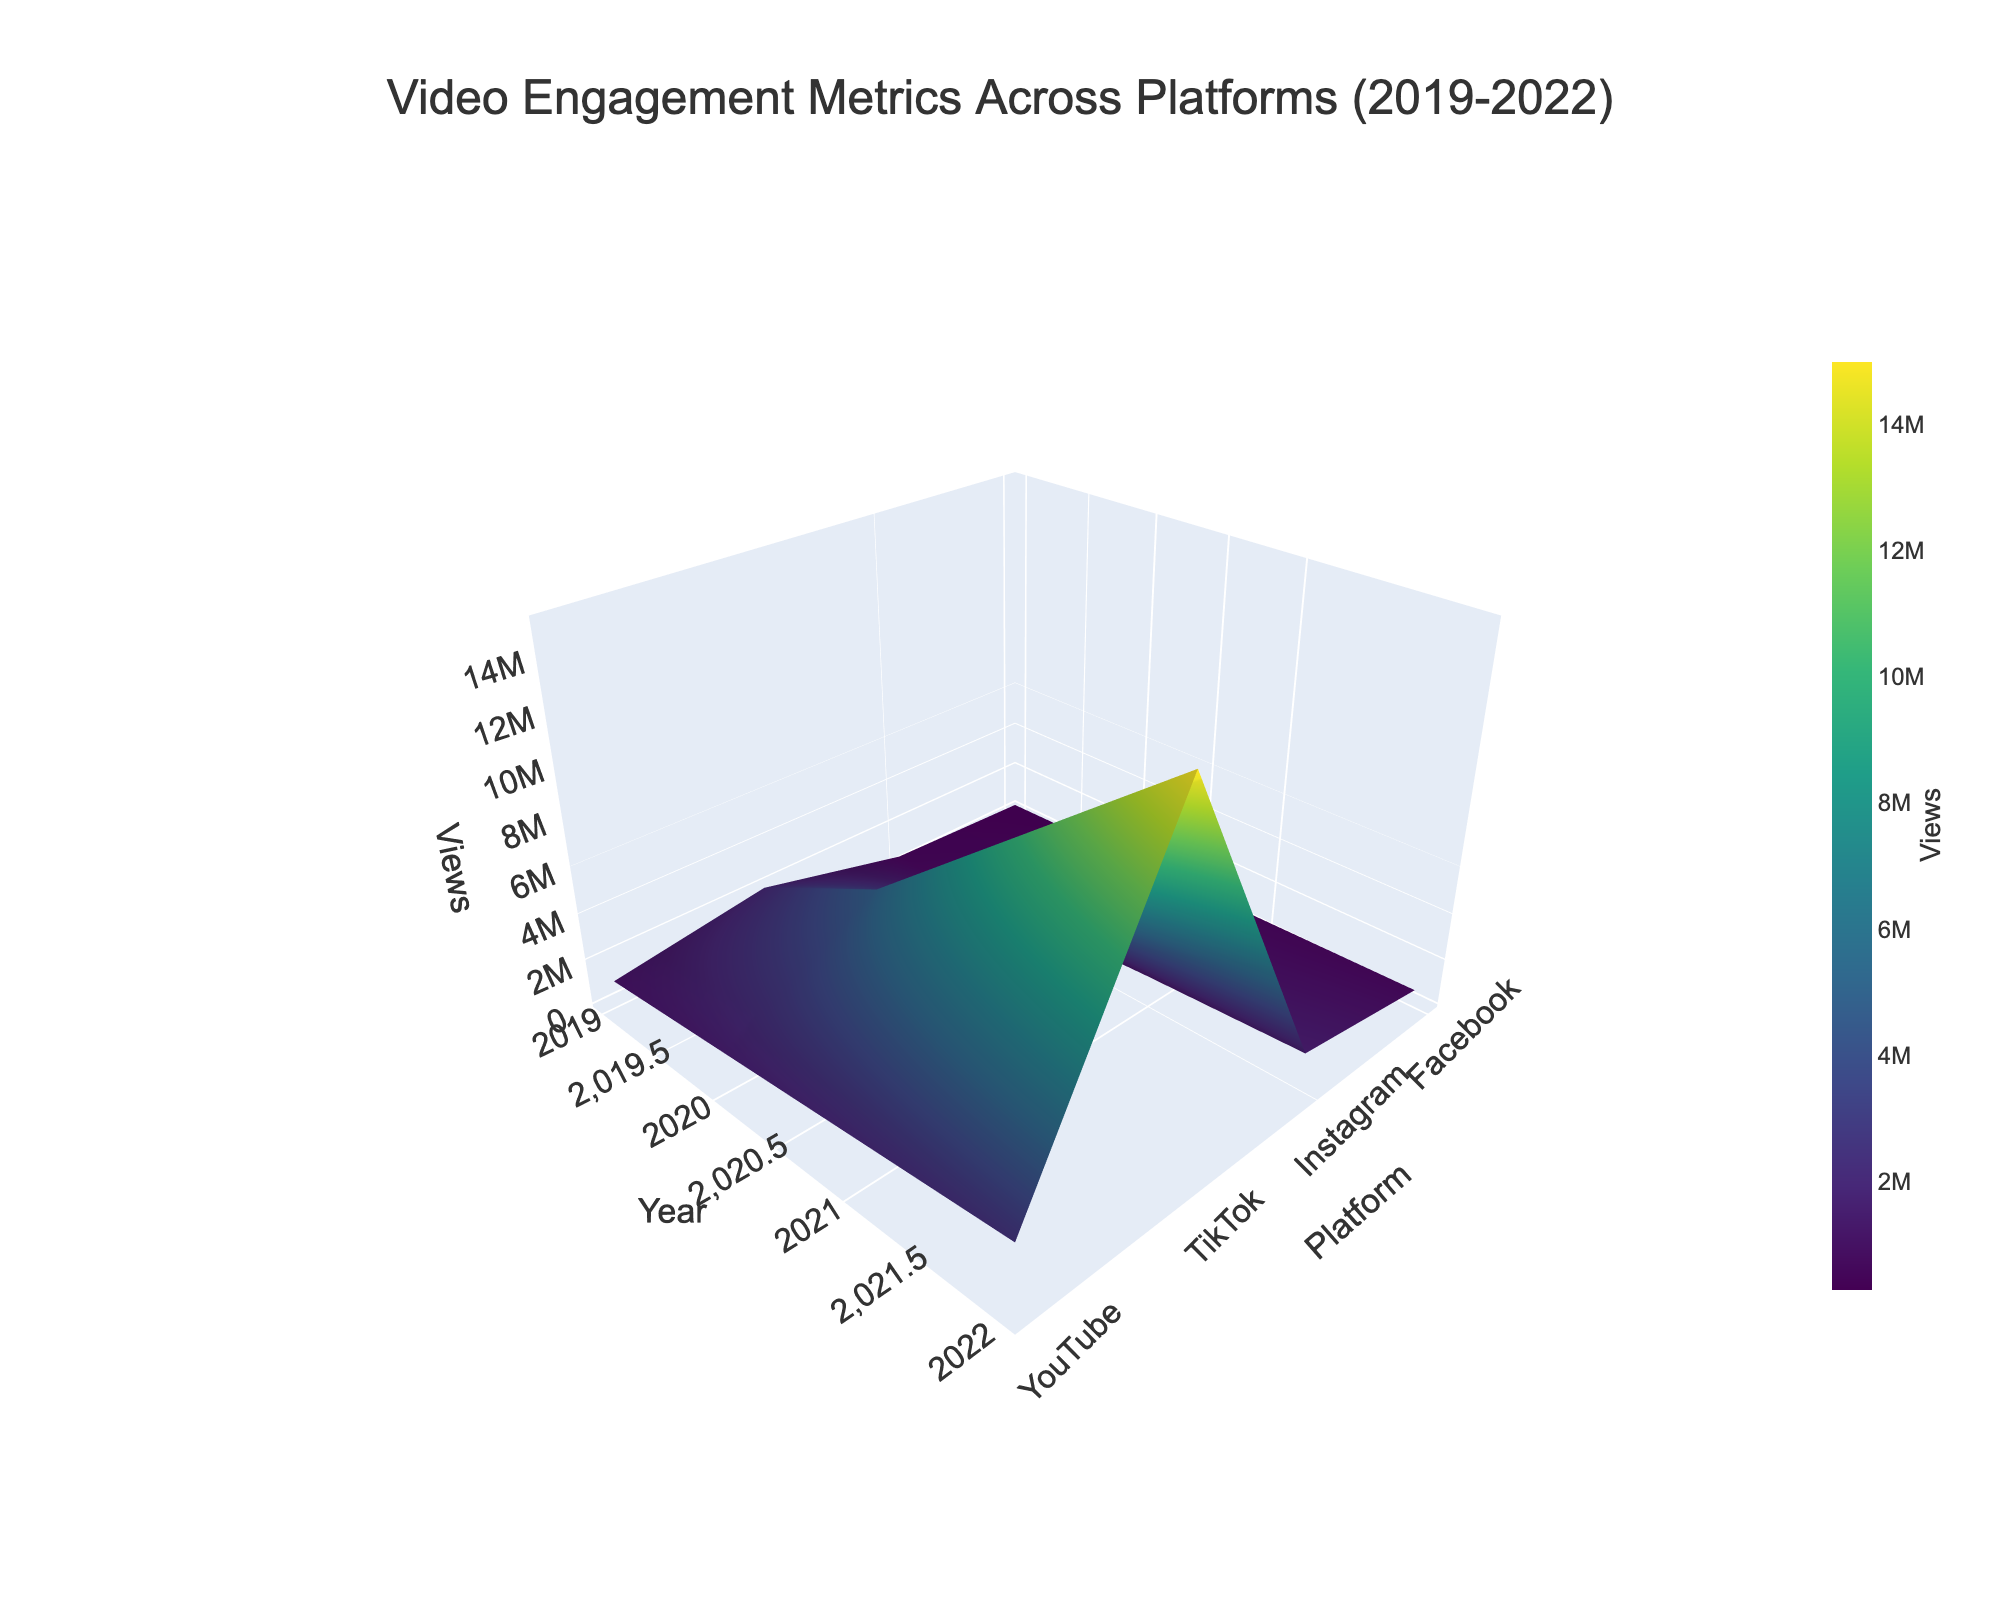What is the title of the figure? The title of the figure is typically displayed at the top of the plot. In this case, it reads "Video Engagement Metrics Across Platforms (2019-2022)."
Answer: Video Engagement Metrics Across Platforms (2019-2022) How many platforms are visualized in this 3D surface plot? The x-axis represents the different platforms, which can be counted as YouTube, Instagram, TikTok, and Facebook, making a total of 4 platforms.
Answer: 4 Which platform had the most views in 2021? By looking at the highest peak for the year 2021 on the surface plot, it corresponds with TikTok. TikTok had the most views out of all platforms in 2021.
Answer: TikTok What is the overall trend in views for YouTube from 2019 to 2022? For YouTube, the z-values (views) increase steadily across the years 2019, 2020, 2021, and 2022, indicating a consistent upward trend in views over these years.
Answer: Increasing trend Compare the views of TikTok and Instagram in 2022. Which platform has more views and by how much? TikTok's value for 2022 is significantly higher compared to Instagram's. TikTok has 15,000,000 views and Instagram has 1,500,000 views. Subtracting the two, TikTok has 13,500,000 more views than Instagram in 2022.
Answer: TikTok by 13,500,000 Which year showed the most significant increase in views for TikTok? To identify the year with the most significant increase, compare the views year-over-year. From 2020 to 2021, the views increased from 5,000,000 to 10,000,000, which is the largest increase (5,000,000) compared to other years.
Answer: From 2020 to 2021 Describe the shape of the trend for Facebook from 2019 to 2022. The surface plot for Facebook shows a gradual increase in views from 2019 to 2020, followed by a flattening or very slight increase from 2020 through 2022. This indicates a slower growth rate or stagnation in views after 2020.
Answer: Gradual increase followed by flattening What can be concluded about the engagement metrics for Instagram in the plot? The surface plot for Instagram shows a steady rise in views from 2019 to 2022. This suggests increasing engagement metrics for Instagram over this period.
Answer: Increasing engagement How does the view count for YouTube in 2022 compare with the view count for Facebook in the same year? For 2022 on the surface plot, YouTube has a much higher peak than Facebook. Specifically, YouTube has 2,500,000 views and Facebook has 600,000 views, showing YouTube leads with 1,900,000 more views.
Answer: YouTube by 1,900,000 Which platform had the least growth in views from 2019 to 2022? To find the platform with the least growth, we visually assess the least difference between the minimum and maximum points over the years for each platform. Facebook shows the least variation, indicating it had the least growth in views from 2019 to 2022.
Answer: Facebook 